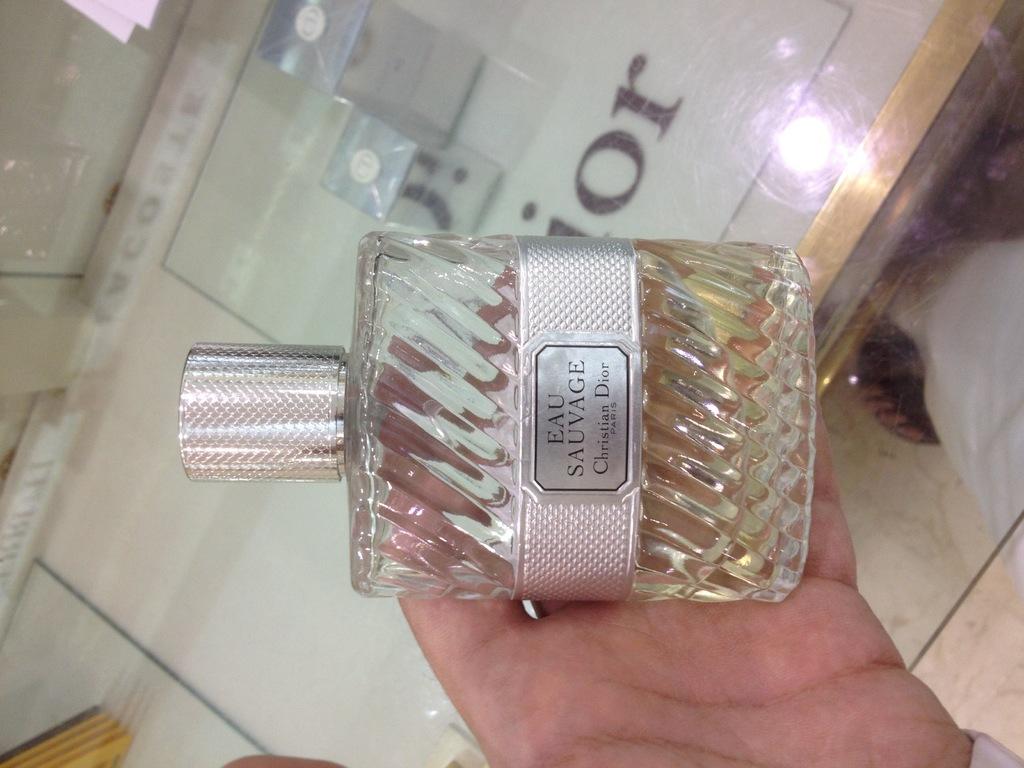What brand of perfume is in the bottle?
Provide a short and direct response. Eau sauvage. What christian dior fragrance is this?
Ensure brevity in your answer.  Eau sauvage. 